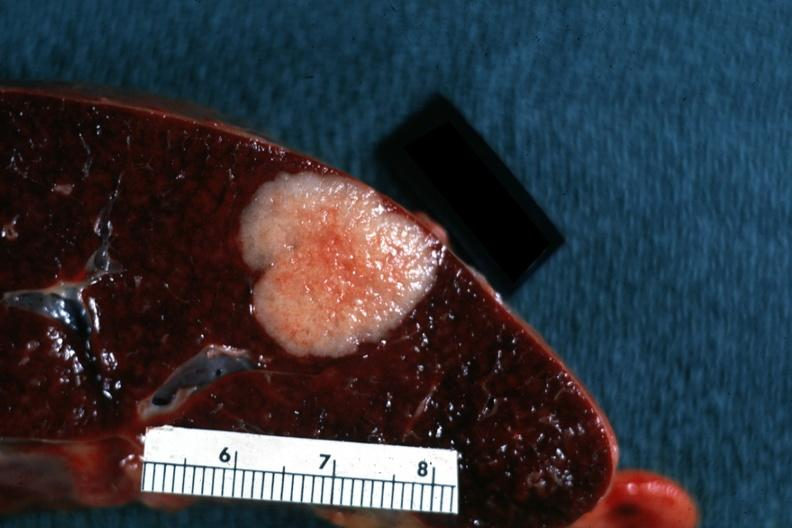does this image show very nice close-up shot of typical metastatic lesion primary tumor in colon?
Answer the question using a single word or phrase. Yes 